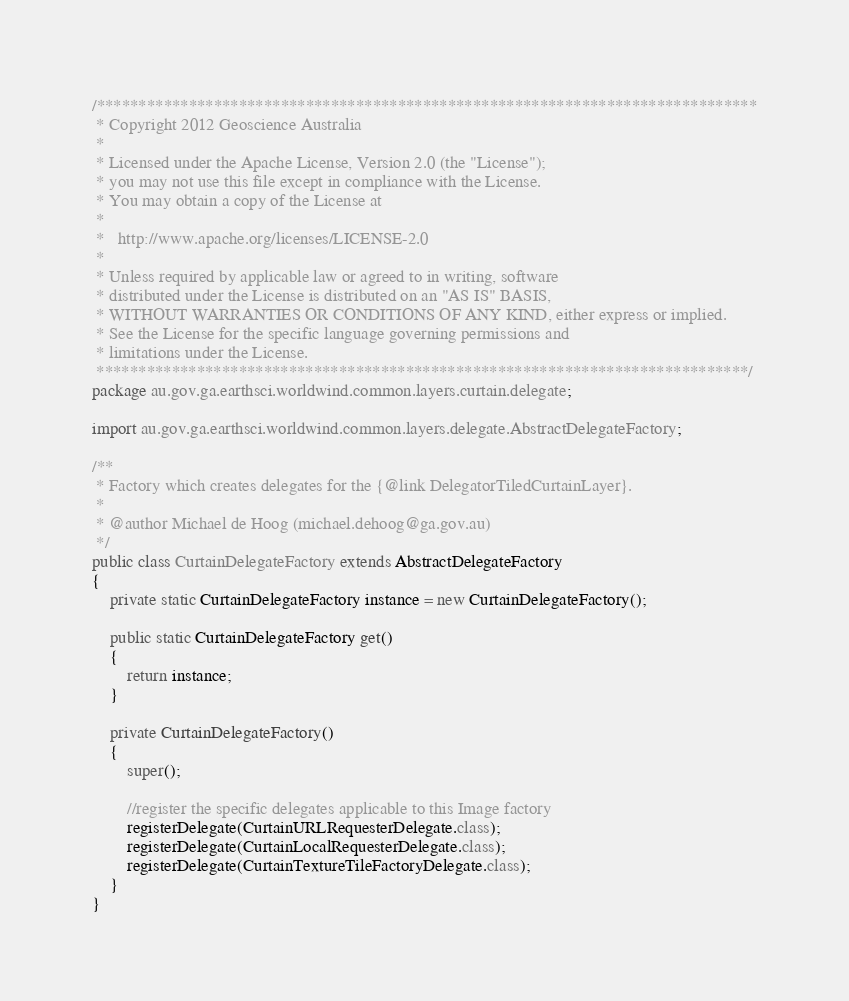<code> <loc_0><loc_0><loc_500><loc_500><_Java_>/*******************************************************************************
 * Copyright 2012 Geoscience Australia
 * 
 * Licensed under the Apache License, Version 2.0 (the "License");
 * you may not use this file except in compliance with the License.
 * You may obtain a copy of the License at
 * 
 *   http://www.apache.org/licenses/LICENSE-2.0
 * 
 * Unless required by applicable law or agreed to in writing, software
 * distributed under the License is distributed on an "AS IS" BASIS,
 * WITHOUT WARRANTIES OR CONDITIONS OF ANY KIND, either express or implied.
 * See the License for the specific language governing permissions and
 * limitations under the License.
 ******************************************************************************/
package au.gov.ga.earthsci.worldwind.common.layers.curtain.delegate;

import au.gov.ga.earthsci.worldwind.common.layers.delegate.AbstractDelegateFactory;

/**
 * Factory which creates delegates for the {@link DelegatorTiledCurtainLayer}.
 * 
 * @author Michael de Hoog (michael.dehoog@ga.gov.au)
 */
public class CurtainDelegateFactory extends AbstractDelegateFactory
{
	private static CurtainDelegateFactory instance = new CurtainDelegateFactory();

	public static CurtainDelegateFactory get()
	{
		return instance;
	}

	private CurtainDelegateFactory()
	{
		super();

		//register the specific delegates applicable to this Image factory
		registerDelegate(CurtainURLRequesterDelegate.class);
		registerDelegate(CurtainLocalRequesterDelegate.class);
		registerDelegate(CurtainTextureTileFactoryDelegate.class);
	}
}
</code> 